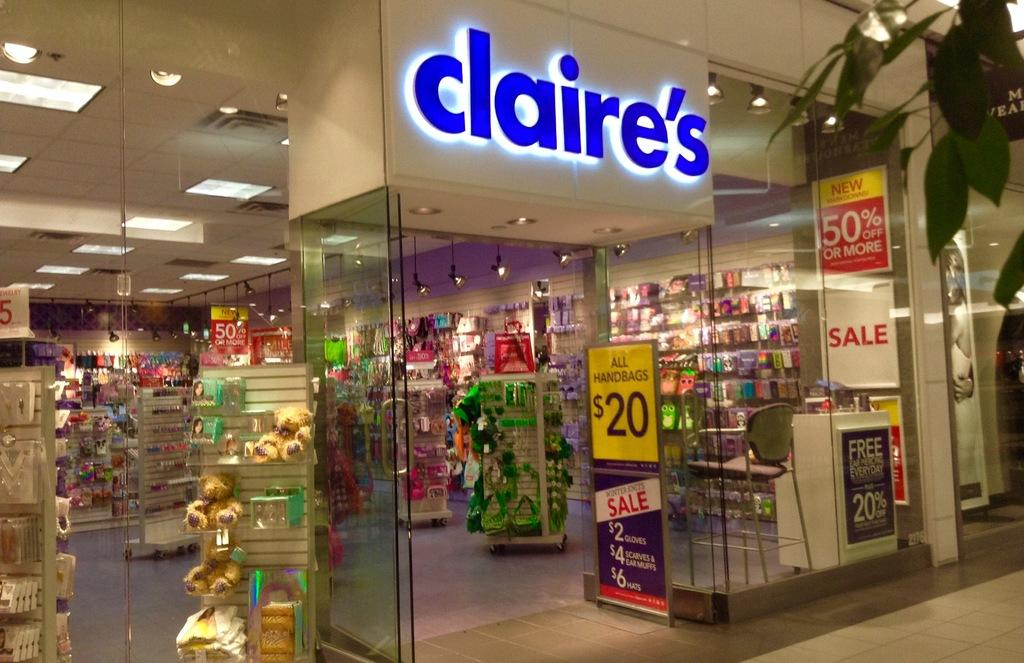<image>
Summarize the visual content of the image. The outside of a store called claire's with 20 dollar handbags 